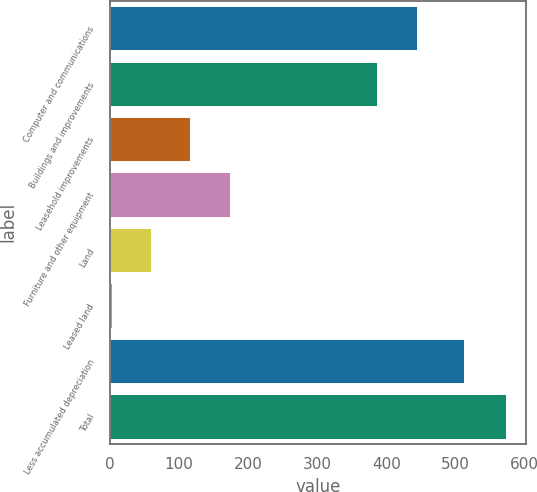Convert chart. <chart><loc_0><loc_0><loc_500><loc_500><bar_chart><fcel>Computer and communications<fcel>Buildings and improvements<fcel>Leasehold improvements<fcel>Furniture and other equipment<fcel>Land<fcel>Leased land<fcel>Less accumulated depreciation<fcel>Total<nl><fcel>443.62<fcel>386.6<fcel>116.74<fcel>173.76<fcel>59.72<fcel>2.7<fcel>511.4<fcel>572.9<nl></chart> 